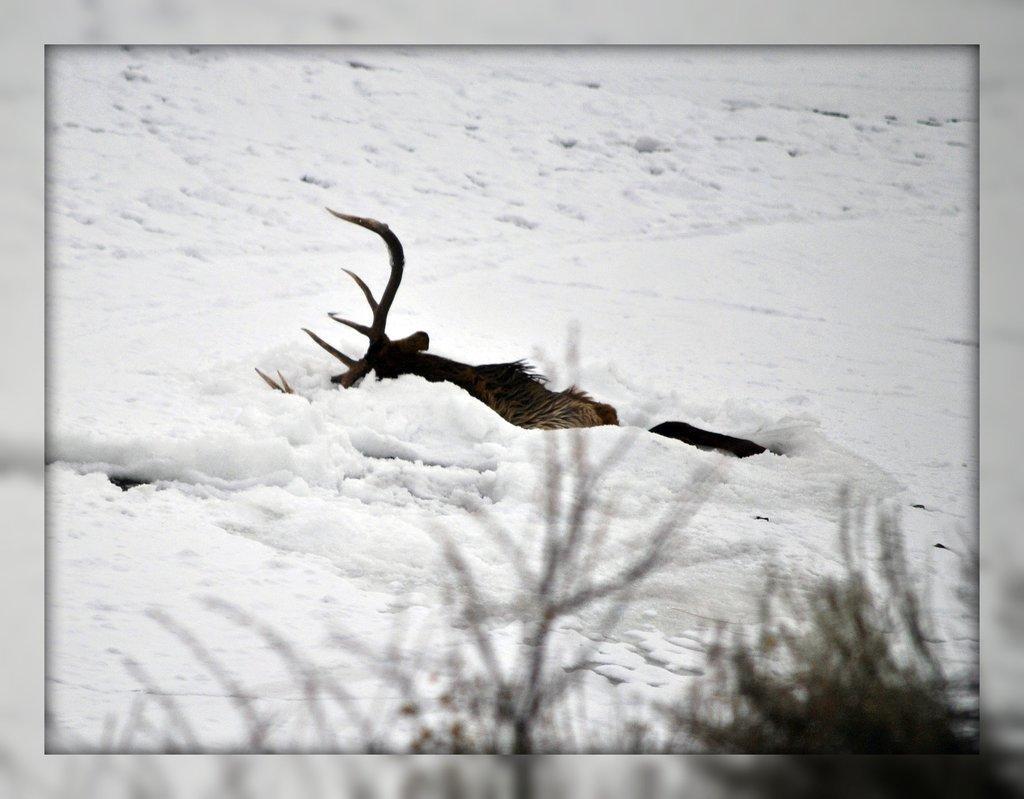Please provide a concise description of this image. In this image I can see an animal in the snow. An animal is in black and brown color. To the side I can see the plants. 